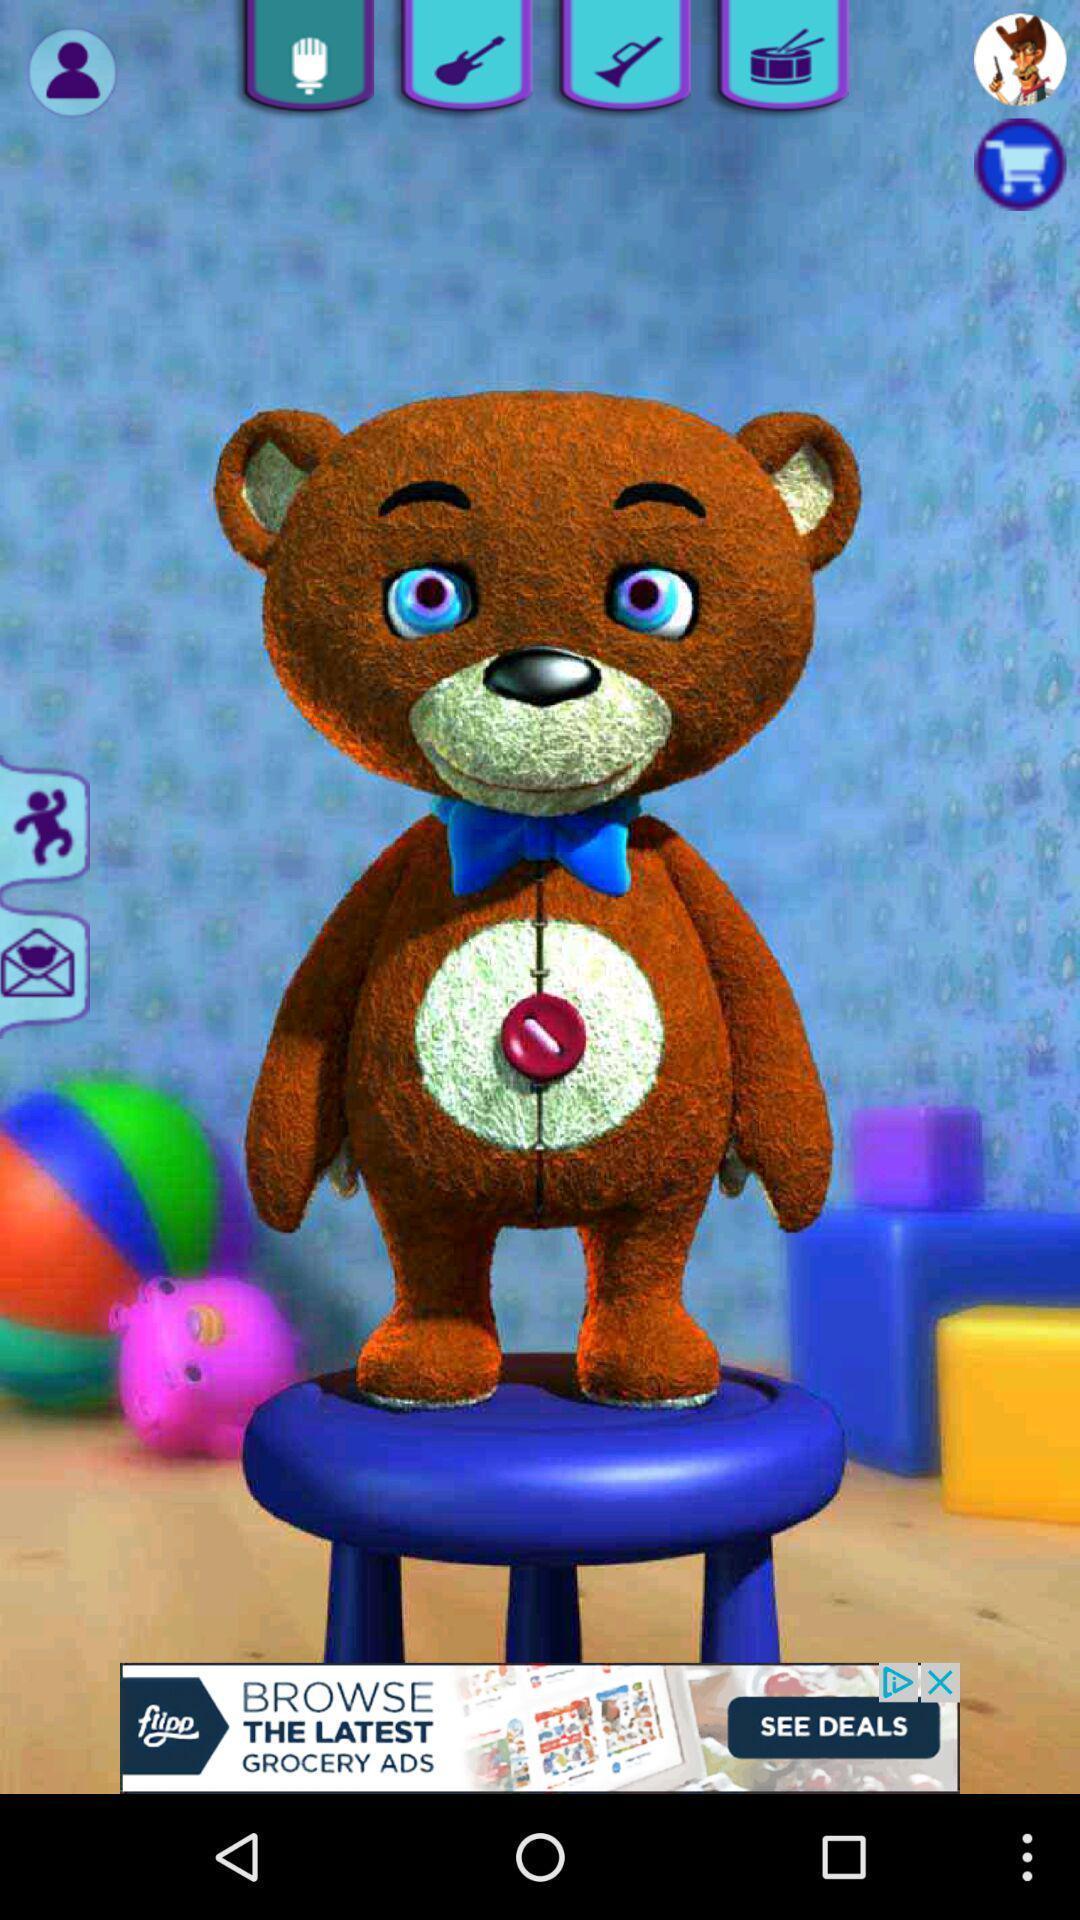Explain what's happening in this screen capture. Page showing image of an animated teddy bear on app. 